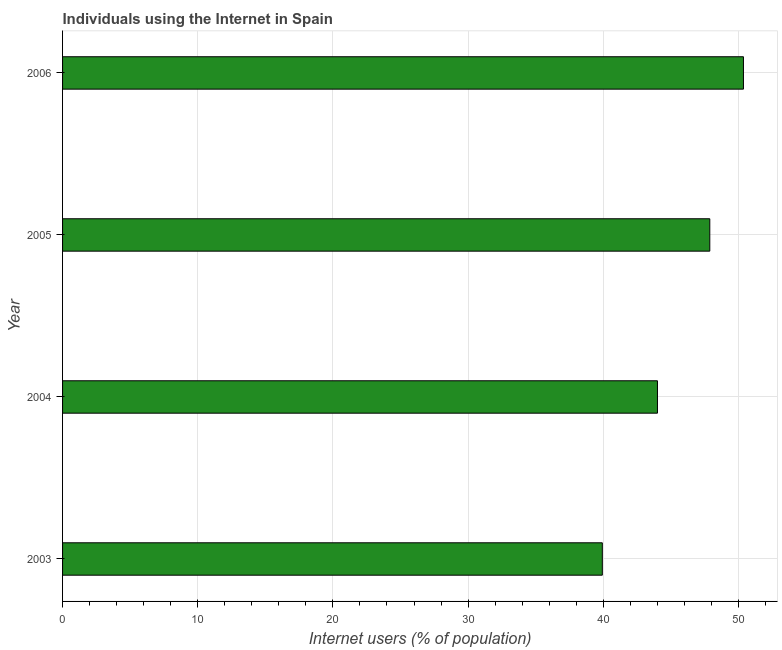What is the title of the graph?
Offer a terse response. Individuals using the Internet in Spain. What is the label or title of the X-axis?
Ensure brevity in your answer.  Internet users (% of population). What is the number of internet users in 2004?
Provide a short and direct response. 44.01. Across all years, what is the maximum number of internet users?
Your answer should be very brief. 50.37. Across all years, what is the minimum number of internet users?
Provide a succinct answer. 39.93. In which year was the number of internet users minimum?
Your response must be concise. 2003. What is the sum of the number of internet users?
Give a very brief answer. 182.19. What is the difference between the number of internet users in 2003 and 2004?
Give a very brief answer. -4.08. What is the average number of internet users per year?
Offer a terse response. 45.55. What is the median number of internet users?
Make the answer very short. 45.95. In how many years, is the number of internet users greater than 48 %?
Keep it short and to the point. 1. Do a majority of the years between 2003 and 2006 (inclusive) have number of internet users greater than 32 %?
Provide a succinct answer. Yes. What is the ratio of the number of internet users in 2003 to that in 2005?
Your answer should be very brief. 0.83. What is the difference between the highest and the second highest number of internet users?
Make the answer very short. 2.49. Is the sum of the number of internet users in 2004 and 2006 greater than the maximum number of internet users across all years?
Offer a very short reply. Yes. What is the difference between the highest and the lowest number of internet users?
Provide a short and direct response. 10.44. In how many years, is the number of internet users greater than the average number of internet users taken over all years?
Offer a very short reply. 2. Are all the bars in the graph horizontal?
Provide a succinct answer. Yes. What is the Internet users (% of population) of 2003?
Your answer should be compact. 39.93. What is the Internet users (% of population) in 2004?
Give a very brief answer. 44.01. What is the Internet users (% of population) of 2005?
Ensure brevity in your answer.  47.88. What is the Internet users (% of population) of 2006?
Provide a succinct answer. 50.37. What is the difference between the Internet users (% of population) in 2003 and 2004?
Your answer should be very brief. -4.08. What is the difference between the Internet users (% of population) in 2003 and 2005?
Offer a terse response. -7.95. What is the difference between the Internet users (% of population) in 2003 and 2006?
Your answer should be very brief. -10.44. What is the difference between the Internet users (% of population) in 2004 and 2005?
Provide a succinct answer. -3.87. What is the difference between the Internet users (% of population) in 2004 and 2006?
Your answer should be very brief. -6.36. What is the difference between the Internet users (% of population) in 2005 and 2006?
Offer a terse response. -2.49. What is the ratio of the Internet users (% of population) in 2003 to that in 2004?
Ensure brevity in your answer.  0.91. What is the ratio of the Internet users (% of population) in 2003 to that in 2005?
Your answer should be very brief. 0.83. What is the ratio of the Internet users (% of population) in 2003 to that in 2006?
Your answer should be very brief. 0.79. What is the ratio of the Internet users (% of population) in 2004 to that in 2005?
Your answer should be compact. 0.92. What is the ratio of the Internet users (% of population) in 2004 to that in 2006?
Make the answer very short. 0.87. What is the ratio of the Internet users (% of population) in 2005 to that in 2006?
Give a very brief answer. 0.95. 